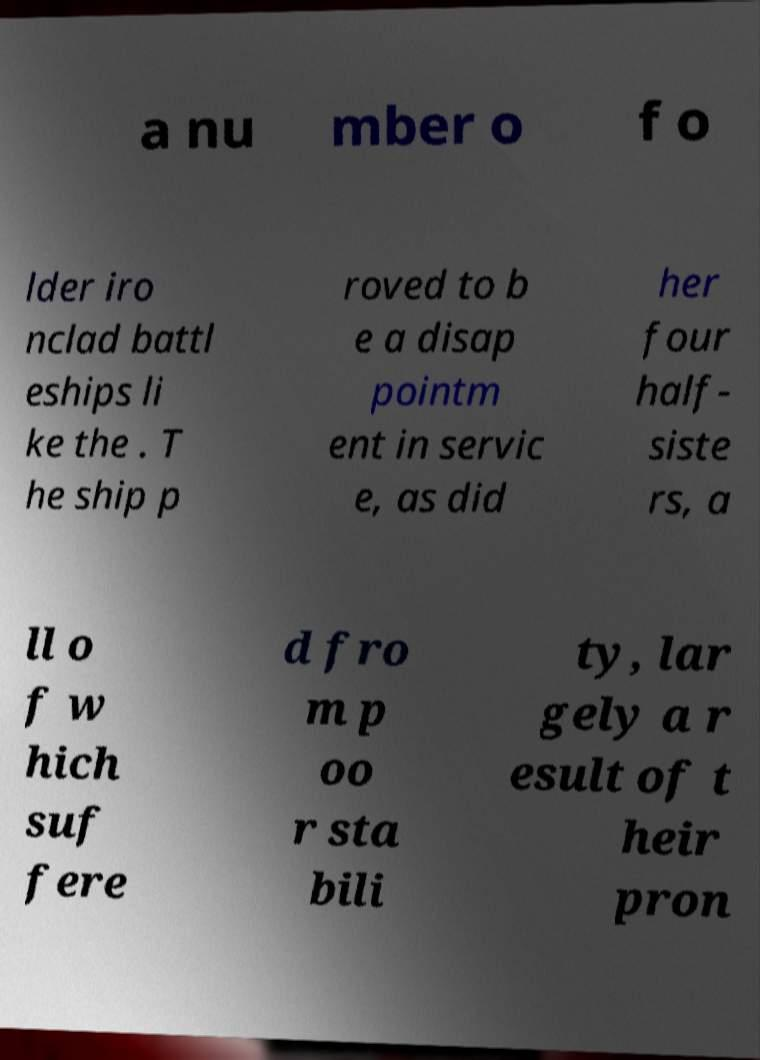There's text embedded in this image that I need extracted. Can you transcribe it verbatim? a nu mber o f o lder iro nclad battl eships li ke the . T he ship p roved to b e a disap pointm ent in servic e, as did her four half- siste rs, a ll o f w hich suf fere d fro m p oo r sta bili ty, lar gely a r esult of t heir pron 